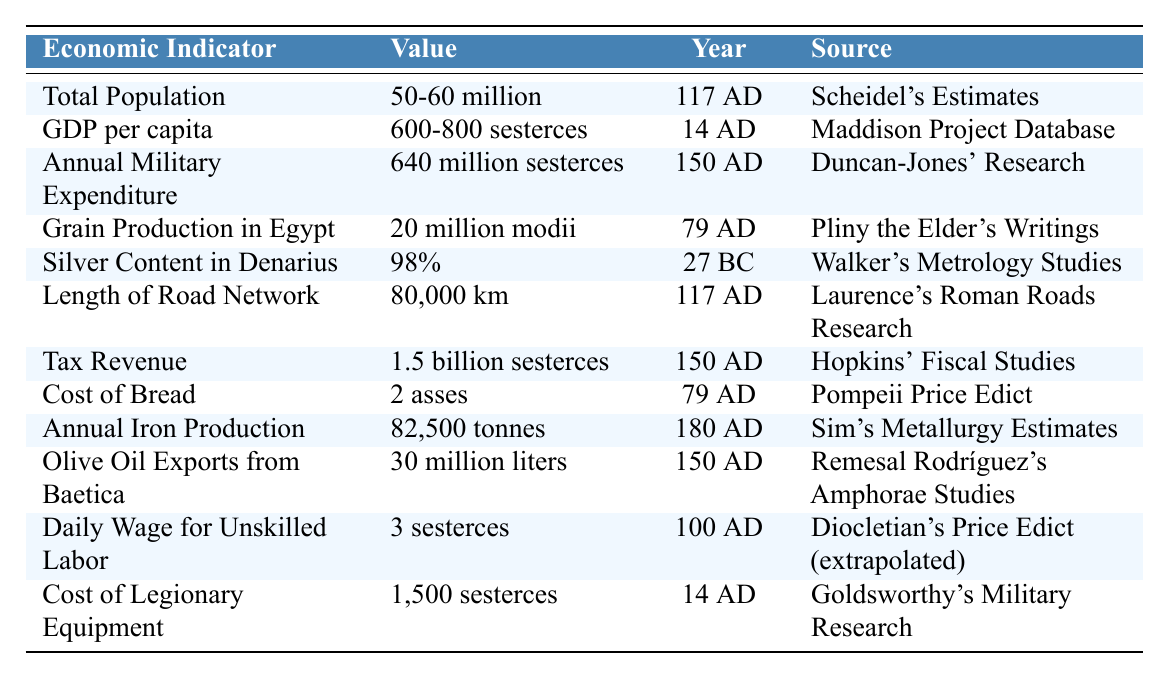What was the total population of the Roman Empire in 117 AD? According to the table, the total population is listed as "50-60 million" for the year 117 AD.
Answer: 50-60 million What was the GDP per capita in 14 AD? The GDP per capita for the year 14 AD is clearly stated as "600-800 sesterces" in the table.
Answer: 600-800 sesterces What is the annual military expenditure in 150 AD? The table specifies that the annual military expenditure for the year 150 AD was "640 million sesterces."
Answer: 640 million sesterces Did the silver content in the denarius change from 27 BC to 180 AD? The table shows that the silver content in the denarius was 98% in 27 BC, but does not provide information for 180 AD, indicating no documented change in the data presented.
Answer: Not enough information How much grain was produced in Egypt in 79 AD compared to the annual iron production in 180 AD? The table provides grain production in Egypt as "20 million modii" for 79 AD and annual iron production as "82,500 tonnes" for 180 AD. Since these are different measurements, a direct comparison is not numerically possible.
Answer: Not directly comparable What is the difference between tax revenue and annual military expenditure in 150 AD? Tax revenue is listed as "1.5 billion sesterces" and annual military expenditure as "640 million sesterces." To find the difference, convert both to the same unit (sesterces); the difference is 1.5 billion - 640 million = 860 million sesterces.
Answer: 860 million sesterces What was the cost of legionary equipment in 14 AD compared to the daily wage for unskilled labor in 100 AD? Cost of legionary equipment in 14 AD is "1,500 sesterces" while the daily wage in 100 AD is "3 sesterces." This shows that legionary equipment was significantly more expensive than the daily wage.
Answer: Significantly more expensive Is it true that the length of the road network was over 70,000 km? The table states the length of the road network was "80,000 km," which confirms this statement.
Answer: True Can you compute the average GDP per capita from the given range in 14 AD? The GDP per capita in the table ranges from 600 to 800 sesterces. To find the average, we add these two values and divide by 2: (600 + 800) / 2 = 700 sesterces.
Answer: 700 sesterces How does the cost of bread in 79 AD compare to the cost of legionary equipment in 14 AD? The cost of bread is "2 asses," while the cost of legionary equipment is "1,500 sesterces." Since the two are presented in different currencies and without a direct conversion, the comparison highlights the relative affordability of daily bread compared to military gear.
Answer: Not directly comparable What was the total olive oil exports from Baetica in 150 AD? The table indicates that the olive oil exports from Baetica in 150 AD were "30 million liters."
Answer: 30 million liters 